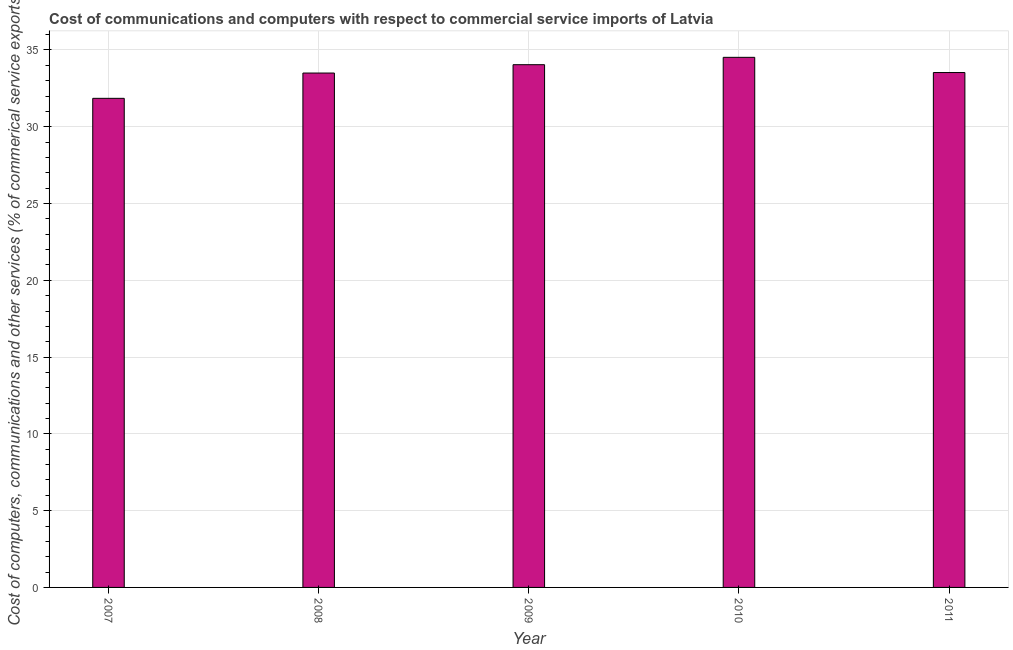What is the title of the graph?
Your answer should be very brief. Cost of communications and computers with respect to commercial service imports of Latvia. What is the label or title of the Y-axis?
Give a very brief answer. Cost of computers, communications and other services (% of commerical service exports). What is the cost of communications in 2009?
Ensure brevity in your answer.  34.04. Across all years, what is the maximum  computer and other services?
Give a very brief answer. 34.52. Across all years, what is the minimum  computer and other services?
Offer a very short reply. 31.85. In which year was the cost of communications maximum?
Ensure brevity in your answer.  2010. In which year was the  computer and other services minimum?
Offer a very short reply. 2007. What is the sum of the cost of communications?
Offer a terse response. 167.44. What is the difference between the  computer and other services in 2007 and 2008?
Your answer should be very brief. -1.65. What is the average cost of communications per year?
Offer a very short reply. 33.49. What is the median  computer and other services?
Offer a terse response. 33.53. Do a majority of the years between 2008 and 2009 (inclusive) have cost of communications greater than 5 %?
Make the answer very short. Yes. Is the difference between the  computer and other services in 2007 and 2010 greater than the difference between any two years?
Make the answer very short. Yes. What is the difference between the highest and the second highest  computer and other services?
Offer a terse response. 0.48. Is the sum of the cost of communications in 2007 and 2011 greater than the maximum cost of communications across all years?
Give a very brief answer. Yes. What is the difference between the highest and the lowest cost of communications?
Give a very brief answer. 2.67. In how many years, is the cost of communications greater than the average cost of communications taken over all years?
Provide a succinct answer. 4. How many bars are there?
Ensure brevity in your answer.  5. How many years are there in the graph?
Give a very brief answer. 5. What is the difference between two consecutive major ticks on the Y-axis?
Offer a very short reply. 5. Are the values on the major ticks of Y-axis written in scientific E-notation?
Your answer should be very brief. No. What is the Cost of computers, communications and other services (% of commerical service exports) in 2007?
Your response must be concise. 31.85. What is the Cost of computers, communications and other services (% of commerical service exports) in 2008?
Offer a terse response. 33.5. What is the Cost of computers, communications and other services (% of commerical service exports) in 2009?
Your response must be concise. 34.04. What is the Cost of computers, communications and other services (% of commerical service exports) of 2010?
Your response must be concise. 34.52. What is the Cost of computers, communications and other services (% of commerical service exports) in 2011?
Ensure brevity in your answer.  33.53. What is the difference between the Cost of computers, communications and other services (% of commerical service exports) in 2007 and 2008?
Your answer should be compact. -1.65. What is the difference between the Cost of computers, communications and other services (% of commerical service exports) in 2007 and 2009?
Your answer should be very brief. -2.19. What is the difference between the Cost of computers, communications and other services (% of commerical service exports) in 2007 and 2010?
Offer a terse response. -2.67. What is the difference between the Cost of computers, communications and other services (% of commerical service exports) in 2007 and 2011?
Provide a short and direct response. -1.68. What is the difference between the Cost of computers, communications and other services (% of commerical service exports) in 2008 and 2009?
Keep it short and to the point. -0.54. What is the difference between the Cost of computers, communications and other services (% of commerical service exports) in 2008 and 2010?
Provide a short and direct response. -1.02. What is the difference between the Cost of computers, communications and other services (% of commerical service exports) in 2008 and 2011?
Keep it short and to the point. -0.03. What is the difference between the Cost of computers, communications and other services (% of commerical service exports) in 2009 and 2010?
Your answer should be very brief. -0.48. What is the difference between the Cost of computers, communications and other services (% of commerical service exports) in 2009 and 2011?
Provide a succinct answer. 0.51. What is the difference between the Cost of computers, communications and other services (% of commerical service exports) in 2010 and 2011?
Your answer should be very brief. 0.99. What is the ratio of the Cost of computers, communications and other services (% of commerical service exports) in 2007 to that in 2008?
Offer a very short reply. 0.95. What is the ratio of the Cost of computers, communications and other services (% of commerical service exports) in 2007 to that in 2009?
Provide a succinct answer. 0.94. What is the ratio of the Cost of computers, communications and other services (% of commerical service exports) in 2007 to that in 2010?
Your answer should be very brief. 0.92. 